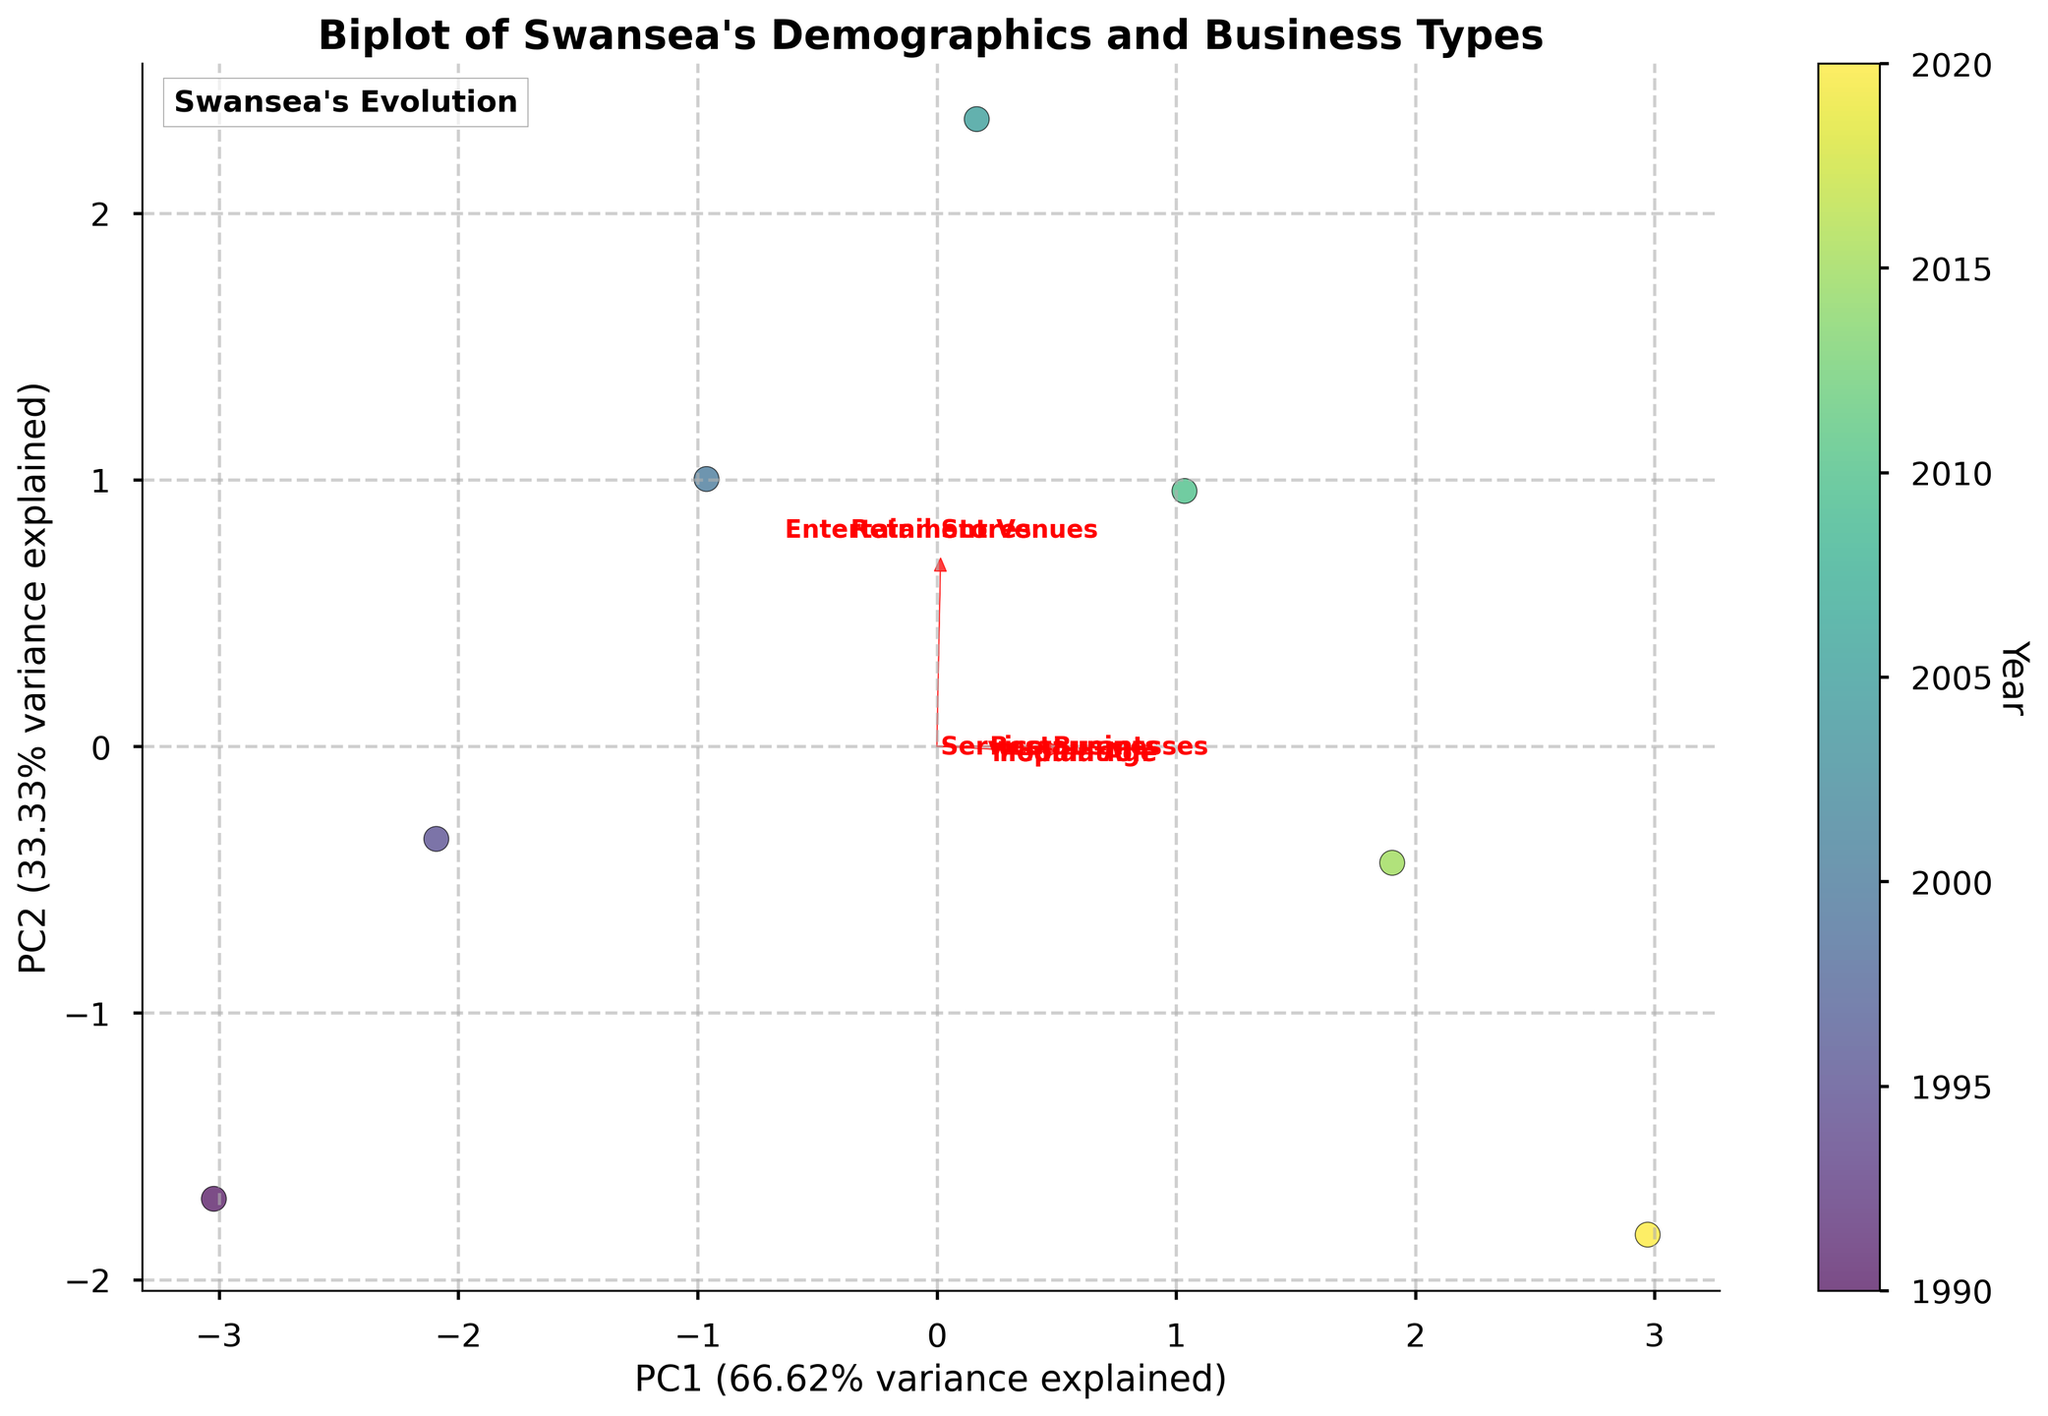What does the title of the plot say? The title usually provides a summary of the content or the main focus of the plot. In this case, it should state what the plot is about, which is likely the relationship between Swansea's population demographics and local business types.
Answer: "Biplot of Swansea's Demographics and Business Types" How many different years are represented in the plot? To determine this, one should look at the colorbar or the legend in the plot, which typically indicates the years. Each unique color in the plot represents a different year.
Answer: 7 years What feature has the longest arrow in the biplot? The length of the arrows in a biplot indicates the extent of the feature's contribution to the principal components. The longest arrow represents the feature with the strongest influence.
Answer: Entertainment Venues Which year is represented by the data point with the highest PC1 value? The highest PC1 value is the furthest to the right on the x-axis. By looking at the color gradient or labels near this point, one can identify the year it represents.
Answer: 2010 Which two features are most closely aligned with PC1? Features aligned with PC1 will have arrows pointing in the direction of the PC1 axis, often in the rightward or leftward direction, and will usually have the longest projections along this axis.
Answer: Retail Stores and Service Businesses What is the percentage variance explained by PC1 and PC2 combined? The x and y-axis labels in the plot often include the percentage of variance that each principal component explains. Adding these two percentages gives the total explained variance.
Answer: ~98% (69% + 29%) How did the number of Restaurants change from 1990 to 2020? Refer to the color-coded points representing 1990 and 2020, then look at their respective position in relation to the Restaurants feature vector to infer the change.
Answer: Increased from 20 to 35 Which feature shows a strong negative relationship with Median Age? A strong negative relationship is indicated by an arrow pointing in a direction opposite to the Median Age vector.
Answer: Entertainment Venues By how many units did the population grow from 1995 to 2020? Subtract the population value of 1995 from the population value of 2020 to determine the growth.
Answer: 500 units (17300-15800) Which feature seems least correlated with changes in year? The feature whose arrow is shortest and closest to the origin in the biplot is the least correlated with changes over the years.
Answer: Service Businesses 